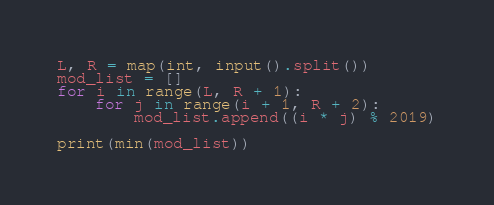Convert code to text. <code><loc_0><loc_0><loc_500><loc_500><_Python_>L, R = map(int, input().split())
mod_list = []
for i in range(L, R + 1):
    for j in range(i + 1, R + 2):
        mod_list.append((i * j) % 2019)

print(min(mod_list))</code> 